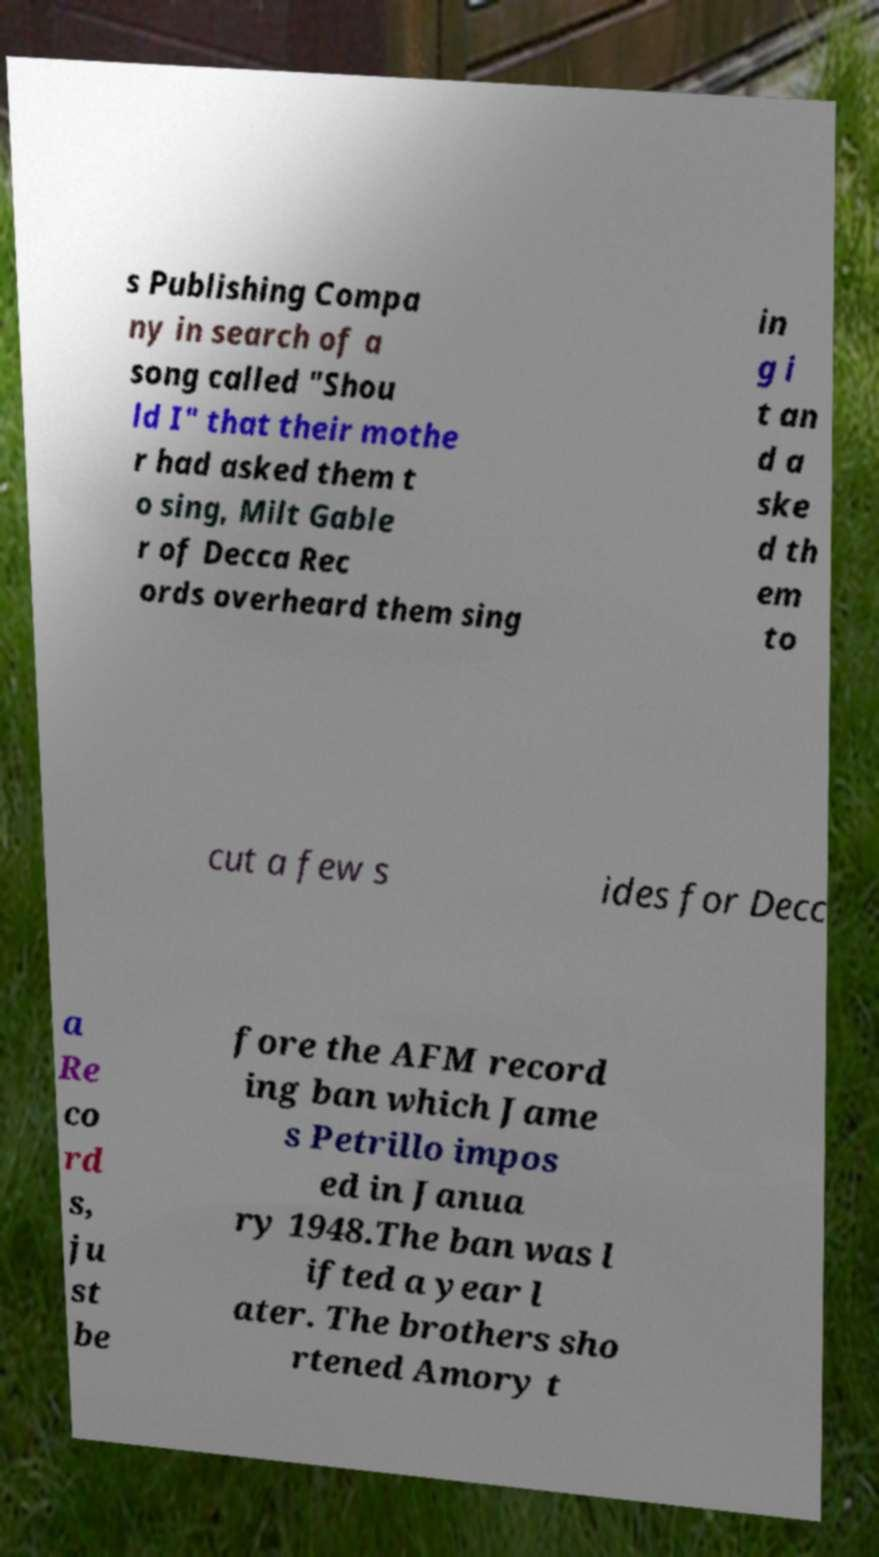I need the written content from this picture converted into text. Can you do that? s Publishing Compa ny in search of a song called "Shou ld I" that their mothe r had asked them t o sing, Milt Gable r of Decca Rec ords overheard them sing in g i t an d a ske d th em to cut a few s ides for Decc a Re co rd s, ju st be fore the AFM record ing ban which Jame s Petrillo impos ed in Janua ry 1948.The ban was l ifted a year l ater. The brothers sho rtened Amory t 